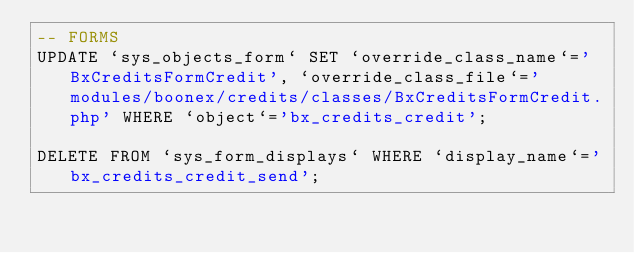<code> <loc_0><loc_0><loc_500><loc_500><_SQL_>-- FORMS
UPDATE `sys_objects_form` SET `override_class_name`='BxCreditsFormCredit', `override_class_file`='modules/boonex/credits/classes/BxCreditsFormCredit.php' WHERE `object`='bx_credits_credit';

DELETE FROM `sys_form_displays` WHERE `display_name`='bx_credits_credit_send';</code> 